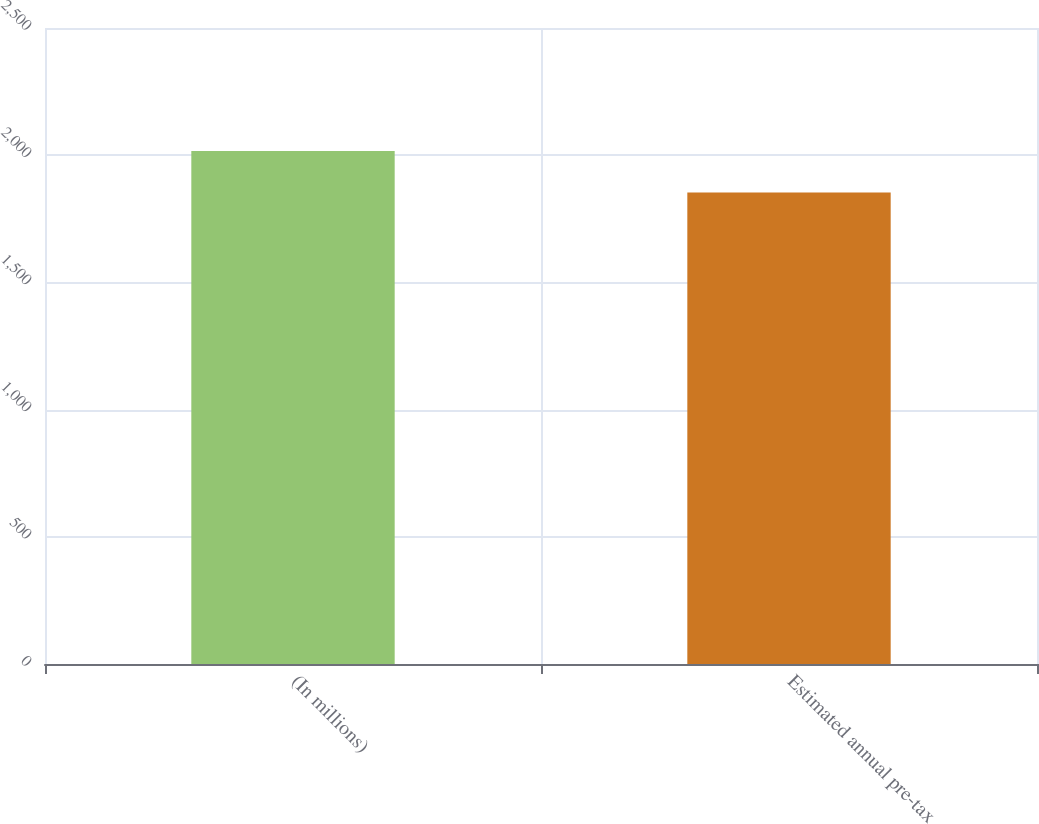Convert chart. <chart><loc_0><loc_0><loc_500><loc_500><bar_chart><fcel>(In millions)<fcel>Estimated annual pre-tax<nl><fcel>2017<fcel>1853<nl></chart> 